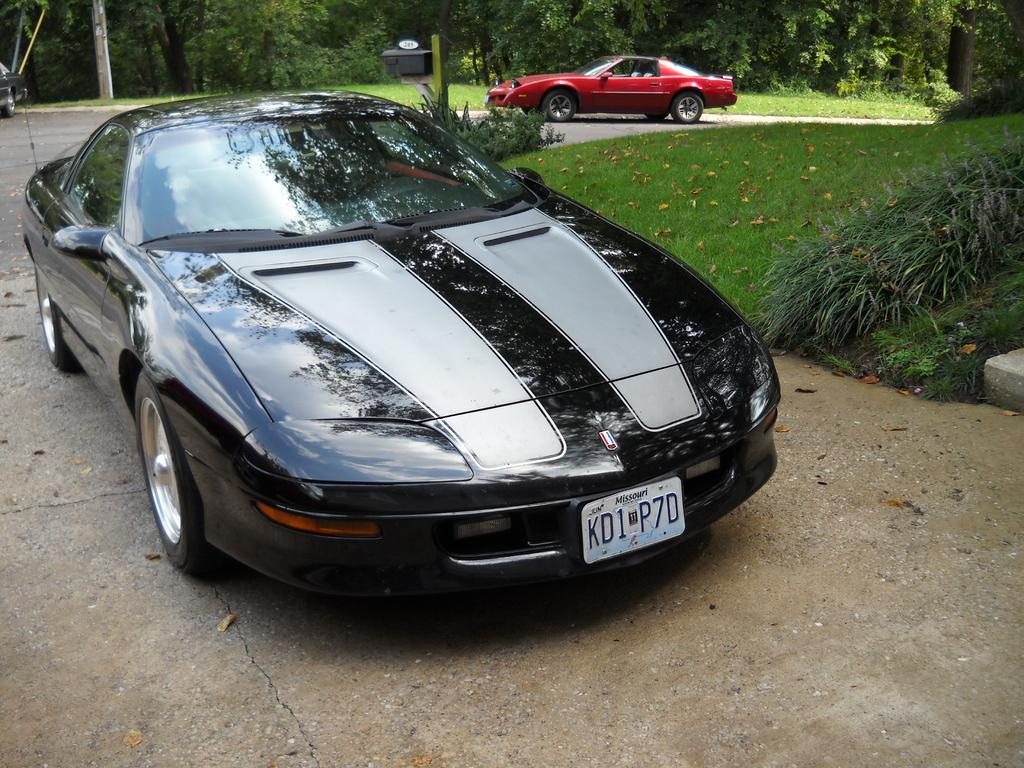What is happening on the road in the image? There are vehicles moving on the road in the image. What type of vegetation can be seen on the right side of the image? There is grass on the right side of the image. What can be seen in the background of the image? There are trees in the background of the image. What type of nerve can be seen in the image? There is no nerve present in the image; it features vehicles moving on the road, grass on the right side, and trees in the background. What observation can be made about the prison in the image? There is no prison present in the image. 